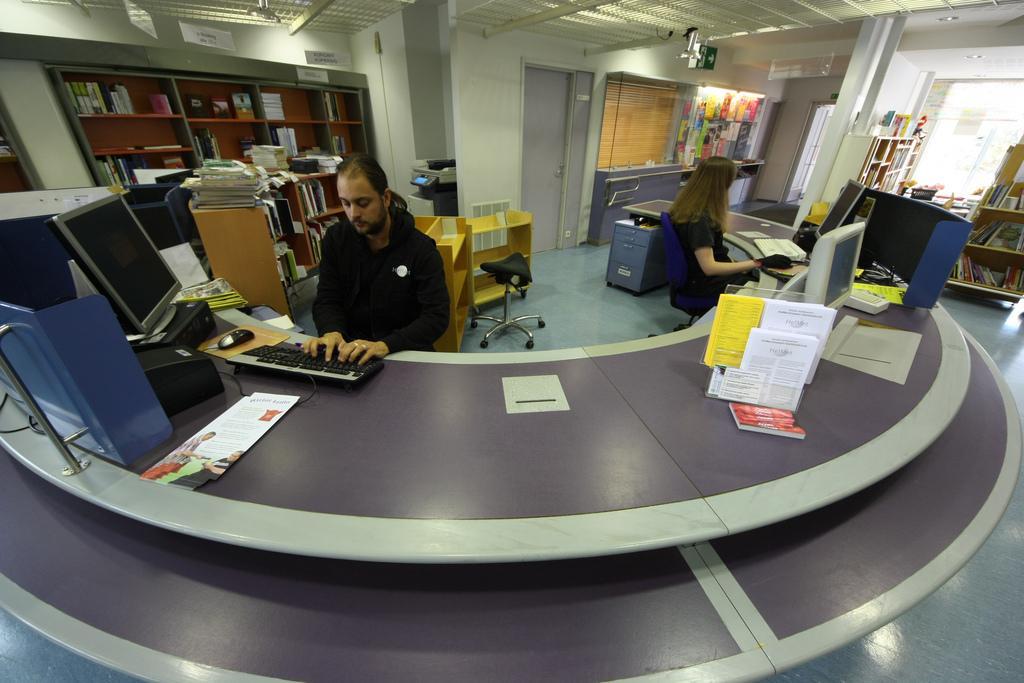Can you describe this image briefly? This 2 persons are sitting on a chair. In-front of them there is a table. On a table there is a keyboard, monitor, screen and mouse. This is a rack. In a race there are books. This are notes on wall. This is a window. This is door. This is a sign board. 